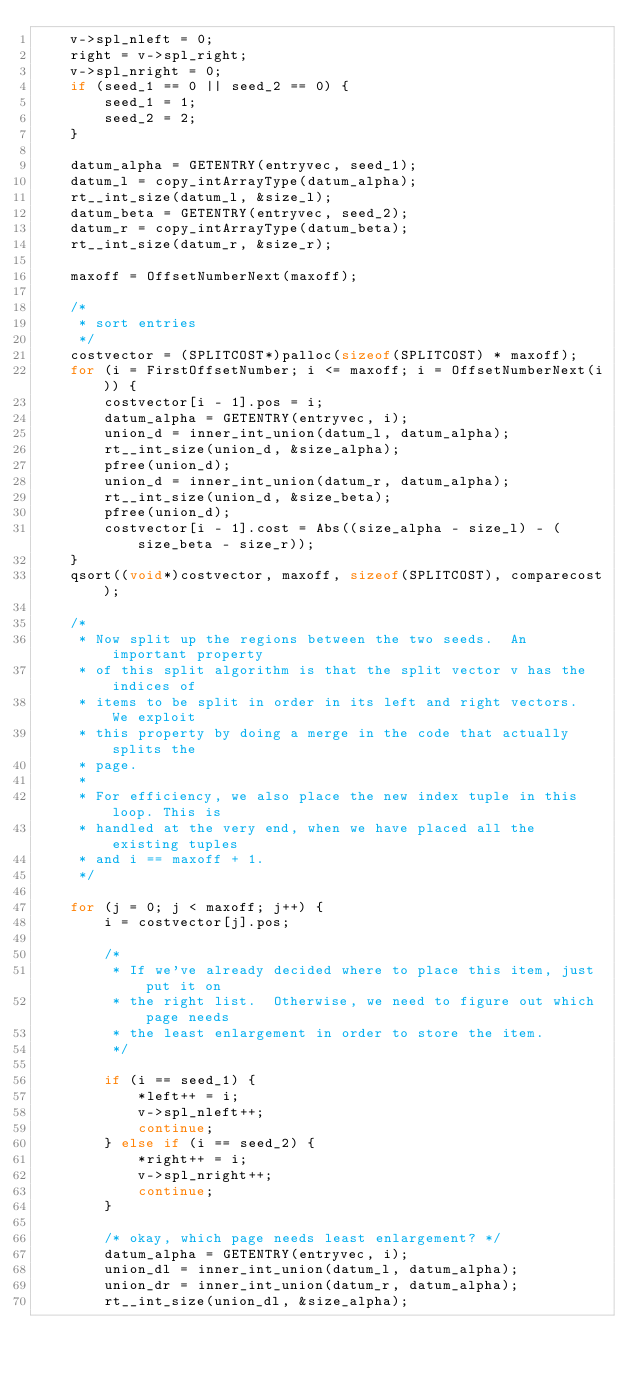Convert code to text. <code><loc_0><loc_0><loc_500><loc_500><_C++_>    v->spl_nleft = 0;
    right = v->spl_right;
    v->spl_nright = 0;
    if (seed_1 == 0 || seed_2 == 0) {
        seed_1 = 1;
        seed_2 = 2;
    }

    datum_alpha = GETENTRY(entryvec, seed_1);
    datum_l = copy_intArrayType(datum_alpha);
    rt__int_size(datum_l, &size_l);
    datum_beta = GETENTRY(entryvec, seed_2);
    datum_r = copy_intArrayType(datum_beta);
    rt__int_size(datum_r, &size_r);

    maxoff = OffsetNumberNext(maxoff);

    /*
     * sort entries
     */
    costvector = (SPLITCOST*)palloc(sizeof(SPLITCOST) * maxoff);
    for (i = FirstOffsetNumber; i <= maxoff; i = OffsetNumberNext(i)) {
        costvector[i - 1].pos = i;
        datum_alpha = GETENTRY(entryvec, i);
        union_d = inner_int_union(datum_l, datum_alpha);
        rt__int_size(union_d, &size_alpha);
        pfree(union_d);
        union_d = inner_int_union(datum_r, datum_alpha);
        rt__int_size(union_d, &size_beta);
        pfree(union_d);
        costvector[i - 1].cost = Abs((size_alpha - size_l) - (size_beta - size_r));
    }
    qsort((void*)costvector, maxoff, sizeof(SPLITCOST), comparecost);

    /*
     * Now split up the regions between the two seeds.	An important property
     * of this split algorithm is that the split vector v has the indices of
     * items to be split in order in its left and right vectors.  We exploit
     * this property by doing a merge in the code that actually splits the
     * page.
     *
     * For efficiency, we also place the new index tuple in this loop. This is
     * handled at the very end, when we have placed all the existing tuples
     * and i == maxoff + 1.
     */

    for (j = 0; j < maxoff; j++) {
        i = costvector[j].pos;

        /*
         * If we've already decided where to place this item, just put it on
         * the right list.	Otherwise, we need to figure out which page needs
         * the least enlargement in order to store the item.
         */

        if (i == seed_1) {
            *left++ = i;
            v->spl_nleft++;
            continue;
        } else if (i == seed_2) {
            *right++ = i;
            v->spl_nright++;
            continue;
        }

        /* okay, which page needs least enlargement? */
        datum_alpha = GETENTRY(entryvec, i);
        union_dl = inner_int_union(datum_l, datum_alpha);
        union_dr = inner_int_union(datum_r, datum_alpha);
        rt__int_size(union_dl, &size_alpha);</code> 